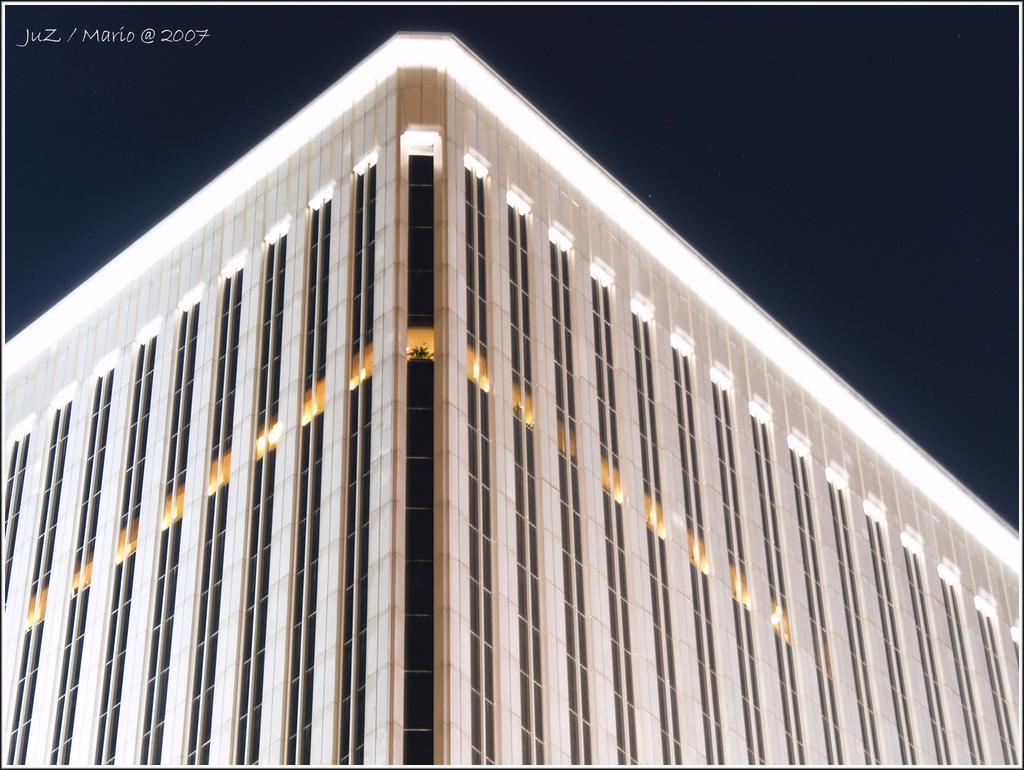What type of structure is visible in the image? There is a building in the image. Can you describe any additional details about the building? Unfortunately, the provided facts do not offer any additional details about the building. Is there any text present in the image? Yes, there is text at the top right corner of the image. How many slaves are depicted in the image? There are no slaves present in the image. What type of basin can be seen in the image? There is no basin present in the image. 